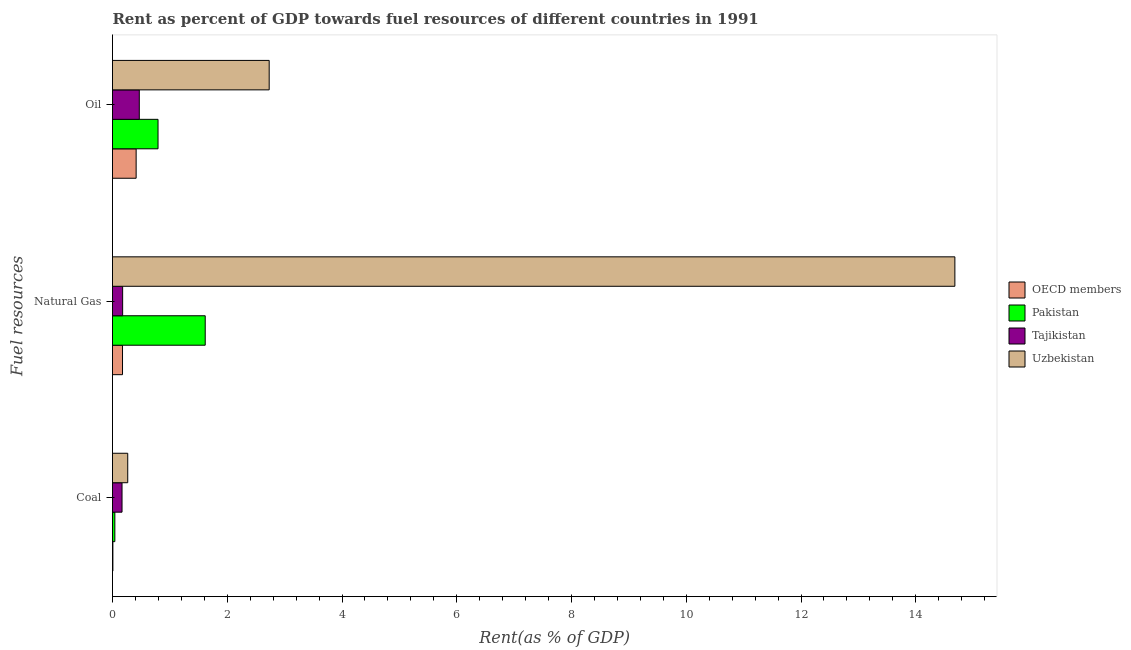How many different coloured bars are there?
Keep it short and to the point. 4. Are the number of bars per tick equal to the number of legend labels?
Your response must be concise. Yes. Are the number of bars on each tick of the Y-axis equal?
Your answer should be compact. Yes. How many bars are there on the 3rd tick from the bottom?
Your answer should be compact. 4. What is the label of the 2nd group of bars from the top?
Provide a succinct answer. Natural Gas. What is the rent towards coal in Pakistan?
Provide a short and direct response. 0.04. Across all countries, what is the maximum rent towards oil?
Your answer should be very brief. 2.73. Across all countries, what is the minimum rent towards natural gas?
Offer a terse response. 0.17. In which country was the rent towards coal maximum?
Offer a terse response. Uzbekistan. What is the total rent towards natural gas in the graph?
Provide a short and direct response. 16.65. What is the difference between the rent towards oil in Tajikistan and that in Uzbekistan?
Keep it short and to the point. -2.26. What is the difference between the rent towards coal in OECD members and the rent towards natural gas in Uzbekistan?
Offer a terse response. -14.67. What is the average rent towards coal per country?
Give a very brief answer. 0.12. What is the difference between the rent towards coal and rent towards oil in Pakistan?
Provide a short and direct response. -0.75. What is the ratio of the rent towards natural gas in OECD members to that in Pakistan?
Provide a short and direct response. 0.11. Is the rent towards oil in Pakistan less than that in Tajikistan?
Make the answer very short. No. Is the difference between the rent towards natural gas in Tajikistan and OECD members greater than the difference between the rent towards oil in Tajikistan and OECD members?
Offer a very short reply. No. What is the difference between the highest and the second highest rent towards coal?
Give a very brief answer. 0.1. What is the difference between the highest and the lowest rent towards natural gas?
Provide a succinct answer. 14.51. Is the sum of the rent towards oil in Tajikistan and Uzbekistan greater than the maximum rent towards natural gas across all countries?
Your response must be concise. No. What does the 2nd bar from the top in Coal represents?
Your answer should be compact. Tajikistan. What does the 4th bar from the bottom in Natural Gas represents?
Ensure brevity in your answer.  Uzbekistan. Are all the bars in the graph horizontal?
Your answer should be very brief. Yes. How many countries are there in the graph?
Keep it short and to the point. 4. Are the values on the major ticks of X-axis written in scientific E-notation?
Your response must be concise. No. Does the graph contain grids?
Keep it short and to the point. No. Where does the legend appear in the graph?
Provide a succinct answer. Center right. How many legend labels are there?
Give a very brief answer. 4. What is the title of the graph?
Your answer should be compact. Rent as percent of GDP towards fuel resources of different countries in 1991. Does "Greece" appear as one of the legend labels in the graph?
Offer a terse response. No. What is the label or title of the X-axis?
Offer a terse response. Rent(as % of GDP). What is the label or title of the Y-axis?
Offer a very short reply. Fuel resources. What is the Rent(as % of GDP) of OECD members in Coal?
Your answer should be very brief. 0.01. What is the Rent(as % of GDP) of Pakistan in Coal?
Your answer should be very brief. 0.04. What is the Rent(as % of GDP) of Tajikistan in Coal?
Provide a short and direct response. 0.17. What is the Rent(as % of GDP) of Uzbekistan in Coal?
Ensure brevity in your answer.  0.27. What is the Rent(as % of GDP) in OECD members in Natural Gas?
Keep it short and to the point. 0.17. What is the Rent(as % of GDP) in Pakistan in Natural Gas?
Offer a terse response. 1.62. What is the Rent(as % of GDP) in Tajikistan in Natural Gas?
Provide a short and direct response. 0.18. What is the Rent(as % of GDP) of Uzbekistan in Natural Gas?
Keep it short and to the point. 14.68. What is the Rent(as % of GDP) in OECD members in Oil?
Your answer should be compact. 0.41. What is the Rent(as % of GDP) in Pakistan in Oil?
Provide a short and direct response. 0.79. What is the Rent(as % of GDP) in Tajikistan in Oil?
Ensure brevity in your answer.  0.47. What is the Rent(as % of GDP) of Uzbekistan in Oil?
Make the answer very short. 2.73. Across all Fuel resources, what is the maximum Rent(as % of GDP) of OECD members?
Your response must be concise. 0.41. Across all Fuel resources, what is the maximum Rent(as % of GDP) of Pakistan?
Offer a very short reply. 1.62. Across all Fuel resources, what is the maximum Rent(as % of GDP) of Tajikistan?
Your response must be concise. 0.47. Across all Fuel resources, what is the maximum Rent(as % of GDP) in Uzbekistan?
Provide a succinct answer. 14.68. Across all Fuel resources, what is the minimum Rent(as % of GDP) in OECD members?
Your answer should be compact. 0.01. Across all Fuel resources, what is the minimum Rent(as % of GDP) of Pakistan?
Offer a terse response. 0.04. Across all Fuel resources, what is the minimum Rent(as % of GDP) in Tajikistan?
Make the answer very short. 0.17. Across all Fuel resources, what is the minimum Rent(as % of GDP) in Uzbekistan?
Provide a short and direct response. 0.27. What is the total Rent(as % of GDP) of OECD members in the graph?
Ensure brevity in your answer.  0.59. What is the total Rent(as % of GDP) in Pakistan in the graph?
Your answer should be very brief. 2.45. What is the total Rent(as % of GDP) of Tajikistan in the graph?
Offer a terse response. 0.81. What is the total Rent(as % of GDP) in Uzbekistan in the graph?
Your response must be concise. 17.68. What is the difference between the Rent(as % of GDP) in OECD members in Coal and that in Natural Gas?
Your answer should be very brief. -0.17. What is the difference between the Rent(as % of GDP) in Pakistan in Coal and that in Natural Gas?
Give a very brief answer. -1.58. What is the difference between the Rent(as % of GDP) in Tajikistan in Coal and that in Natural Gas?
Your answer should be very brief. -0.01. What is the difference between the Rent(as % of GDP) in Uzbekistan in Coal and that in Natural Gas?
Make the answer very short. -14.42. What is the difference between the Rent(as % of GDP) of OECD members in Coal and that in Oil?
Your answer should be compact. -0.41. What is the difference between the Rent(as % of GDP) in Pakistan in Coal and that in Oil?
Offer a terse response. -0.75. What is the difference between the Rent(as % of GDP) in Tajikistan in Coal and that in Oil?
Your response must be concise. -0.3. What is the difference between the Rent(as % of GDP) of Uzbekistan in Coal and that in Oil?
Keep it short and to the point. -2.47. What is the difference between the Rent(as % of GDP) of OECD members in Natural Gas and that in Oil?
Your answer should be very brief. -0.24. What is the difference between the Rent(as % of GDP) of Pakistan in Natural Gas and that in Oil?
Ensure brevity in your answer.  0.82. What is the difference between the Rent(as % of GDP) of Tajikistan in Natural Gas and that in Oil?
Your answer should be very brief. -0.29. What is the difference between the Rent(as % of GDP) of Uzbekistan in Natural Gas and that in Oil?
Provide a short and direct response. 11.95. What is the difference between the Rent(as % of GDP) in OECD members in Coal and the Rent(as % of GDP) in Pakistan in Natural Gas?
Make the answer very short. -1.61. What is the difference between the Rent(as % of GDP) of OECD members in Coal and the Rent(as % of GDP) of Tajikistan in Natural Gas?
Give a very brief answer. -0.17. What is the difference between the Rent(as % of GDP) of OECD members in Coal and the Rent(as % of GDP) of Uzbekistan in Natural Gas?
Offer a very short reply. -14.67. What is the difference between the Rent(as % of GDP) in Pakistan in Coal and the Rent(as % of GDP) in Tajikistan in Natural Gas?
Make the answer very short. -0.14. What is the difference between the Rent(as % of GDP) of Pakistan in Coal and the Rent(as % of GDP) of Uzbekistan in Natural Gas?
Provide a short and direct response. -14.64. What is the difference between the Rent(as % of GDP) of Tajikistan in Coal and the Rent(as % of GDP) of Uzbekistan in Natural Gas?
Provide a succinct answer. -14.52. What is the difference between the Rent(as % of GDP) in OECD members in Coal and the Rent(as % of GDP) in Pakistan in Oil?
Keep it short and to the point. -0.79. What is the difference between the Rent(as % of GDP) in OECD members in Coal and the Rent(as % of GDP) in Tajikistan in Oil?
Offer a terse response. -0.46. What is the difference between the Rent(as % of GDP) in OECD members in Coal and the Rent(as % of GDP) in Uzbekistan in Oil?
Your answer should be very brief. -2.72. What is the difference between the Rent(as % of GDP) in Pakistan in Coal and the Rent(as % of GDP) in Tajikistan in Oil?
Your answer should be compact. -0.43. What is the difference between the Rent(as % of GDP) in Pakistan in Coal and the Rent(as % of GDP) in Uzbekistan in Oil?
Give a very brief answer. -2.69. What is the difference between the Rent(as % of GDP) in Tajikistan in Coal and the Rent(as % of GDP) in Uzbekistan in Oil?
Your answer should be compact. -2.56. What is the difference between the Rent(as % of GDP) in OECD members in Natural Gas and the Rent(as % of GDP) in Pakistan in Oil?
Give a very brief answer. -0.62. What is the difference between the Rent(as % of GDP) in OECD members in Natural Gas and the Rent(as % of GDP) in Tajikistan in Oil?
Provide a succinct answer. -0.29. What is the difference between the Rent(as % of GDP) in OECD members in Natural Gas and the Rent(as % of GDP) in Uzbekistan in Oil?
Make the answer very short. -2.56. What is the difference between the Rent(as % of GDP) in Pakistan in Natural Gas and the Rent(as % of GDP) in Tajikistan in Oil?
Offer a very short reply. 1.15. What is the difference between the Rent(as % of GDP) in Pakistan in Natural Gas and the Rent(as % of GDP) in Uzbekistan in Oil?
Provide a succinct answer. -1.11. What is the difference between the Rent(as % of GDP) of Tajikistan in Natural Gas and the Rent(as % of GDP) of Uzbekistan in Oil?
Keep it short and to the point. -2.55. What is the average Rent(as % of GDP) of OECD members per Fuel resources?
Ensure brevity in your answer.  0.2. What is the average Rent(as % of GDP) of Pakistan per Fuel resources?
Offer a terse response. 0.82. What is the average Rent(as % of GDP) in Tajikistan per Fuel resources?
Provide a short and direct response. 0.27. What is the average Rent(as % of GDP) of Uzbekistan per Fuel resources?
Provide a succinct answer. 5.89. What is the difference between the Rent(as % of GDP) of OECD members and Rent(as % of GDP) of Pakistan in Coal?
Make the answer very short. -0.03. What is the difference between the Rent(as % of GDP) of OECD members and Rent(as % of GDP) of Tajikistan in Coal?
Provide a short and direct response. -0.16. What is the difference between the Rent(as % of GDP) of OECD members and Rent(as % of GDP) of Uzbekistan in Coal?
Provide a short and direct response. -0.26. What is the difference between the Rent(as % of GDP) in Pakistan and Rent(as % of GDP) in Tajikistan in Coal?
Offer a terse response. -0.13. What is the difference between the Rent(as % of GDP) of Pakistan and Rent(as % of GDP) of Uzbekistan in Coal?
Make the answer very short. -0.22. What is the difference between the Rent(as % of GDP) in Tajikistan and Rent(as % of GDP) in Uzbekistan in Coal?
Offer a terse response. -0.1. What is the difference between the Rent(as % of GDP) in OECD members and Rent(as % of GDP) in Pakistan in Natural Gas?
Provide a short and direct response. -1.44. What is the difference between the Rent(as % of GDP) of OECD members and Rent(as % of GDP) of Tajikistan in Natural Gas?
Your response must be concise. -0. What is the difference between the Rent(as % of GDP) in OECD members and Rent(as % of GDP) in Uzbekistan in Natural Gas?
Your answer should be very brief. -14.51. What is the difference between the Rent(as % of GDP) of Pakistan and Rent(as % of GDP) of Tajikistan in Natural Gas?
Provide a short and direct response. 1.44. What is the difference between the Rent(as % of GDP) in Pakistan and Rent(as % of GDP) in Uzbekistan in Natural Gas?
Offer a very short reply. -13.07. What is the difference between the Rent(as % of GDP) in Tajikistan and Rent(as % of GDP) in Uzbekistan in Natural Gas?
Your answer should be very brief. -14.5. What is the difference between the Rent(as % of GDP) of OECD members and Rent(as % of GDP) of Pakistan in Oil?
Your response must be concise. -0.38. What is the difference between the Rent(as % of GDP) of OECD members and Rent(as % of GDP) of Tajikistan in Oil?
Make the answer very short. -0.06. What is the difference between the Rent(as % of GDP) of OECD members and Rent(as % of GDP) of Uzbekistan in Oil?
Keep it short and to the point. -2.32. What is the difference between the Rent(as % of GDP) of Pakistan and Rent(as % of GDP) of Tajikistan in Oil?
Offer a very short reply. 0.33. What is the difference between the Rent(as % of GDP) in Pakistan and Rent(as % of GDP) in Uzbekistan in Oil?
Ensure brevity in your answer.  -1.94. What is the difference between the Rent(as % of GDP) in Tajikistan and Rent(as % of GDP) in Uzbekistan in Oil?
Provide a succinct answer. -2.26. What is the ratio of the Rent(as % of GDP) of OECD members in Coal to that in Natural Gas?
Make the answer very short. 0.04. What is the ratio of the Rent(as % of GDP) of Pakistan in Coal to that in Natural Gas?
Offer a terse response. 0.03. What is the ratio of the Rent(as % of GDP) of Tajikistan in Coal to that in Natural Gas?
Provide a short and direct response. 0.94. What is the ratio of the Rent(as % of GDP) in Uzbekistan in Coal to that in Natural Gas?
Provide a short and direct response. 0.02. What is the ratio of the Rent(as % of GDP) of OECD members in Coal to that in Oil?
Offer a very short reply. 0.02. What is the ratio of the Rent(as % of GDP) in Pakistan in Coal to that in Oil?
Provide a short and direct response. 0.05. What is the ratio of the Rent(as % of GDP) of Tajikistan in Coal to that in Oil?
Give a very brief answer. 0.36. What is the ratio of the Rent(as % of GDP) in Uzbekistan in Coal to that in Oil?
Keep it short and to the point. 0.1. What is the ratio of the Rent(as % of GDP) in OECD members in Natural Gas to that in Oil?
Offer a very short reply. 0.42. What is the ratio of the Rent(as % of GDP) of Pakistan in Natural Gas to that in Oil?
Your answer should be very brief. 2.04. What is the ratio of the Rent(as % of GDP) in Tajikistan in Natural Gas to that in Oil?
Your answer should be very brief. 0.38. What is the ratio of the Rent(as % of GDP) in Uzbekistan in Natural Gas to that in Oil?
Give a very brief answer. 5.38. What is the difference between the highest and the second highest Rent(as % of GDP) of OECD members?
Your response must be concise. 0.24. What is the difference between the highest and the second highest Rent(as % of GDP) of Pakistan?
Give a very brief answer. 0.82. What is the difference between the highest and the second highest Rent(as % of GDP) in Tajikistan?
Provide a short and direct response. 0.29. What is the difference between the highest and the second highest Rent(as % of GDP) in Uzbekistan?
Provide a short and direct response. 11.95. What is the difference between the highest and the lowest Rent(as % of GDP) of OECD members?
Your answer should be very brief. 0.41. What is the difference between the highest and the lowest Rent(as % of GDP) in Pakistan?
Make the answer very short. 1.58. What is the difference between the highest and the lowest Rent(as % of GDP) in Tajikistan?
Provide a short and direct response. 0.3. What is the difference between the highest and the lowest Rent(as % of GDP) in Uzbekistan?
Your answer should be compact. 14.42. 